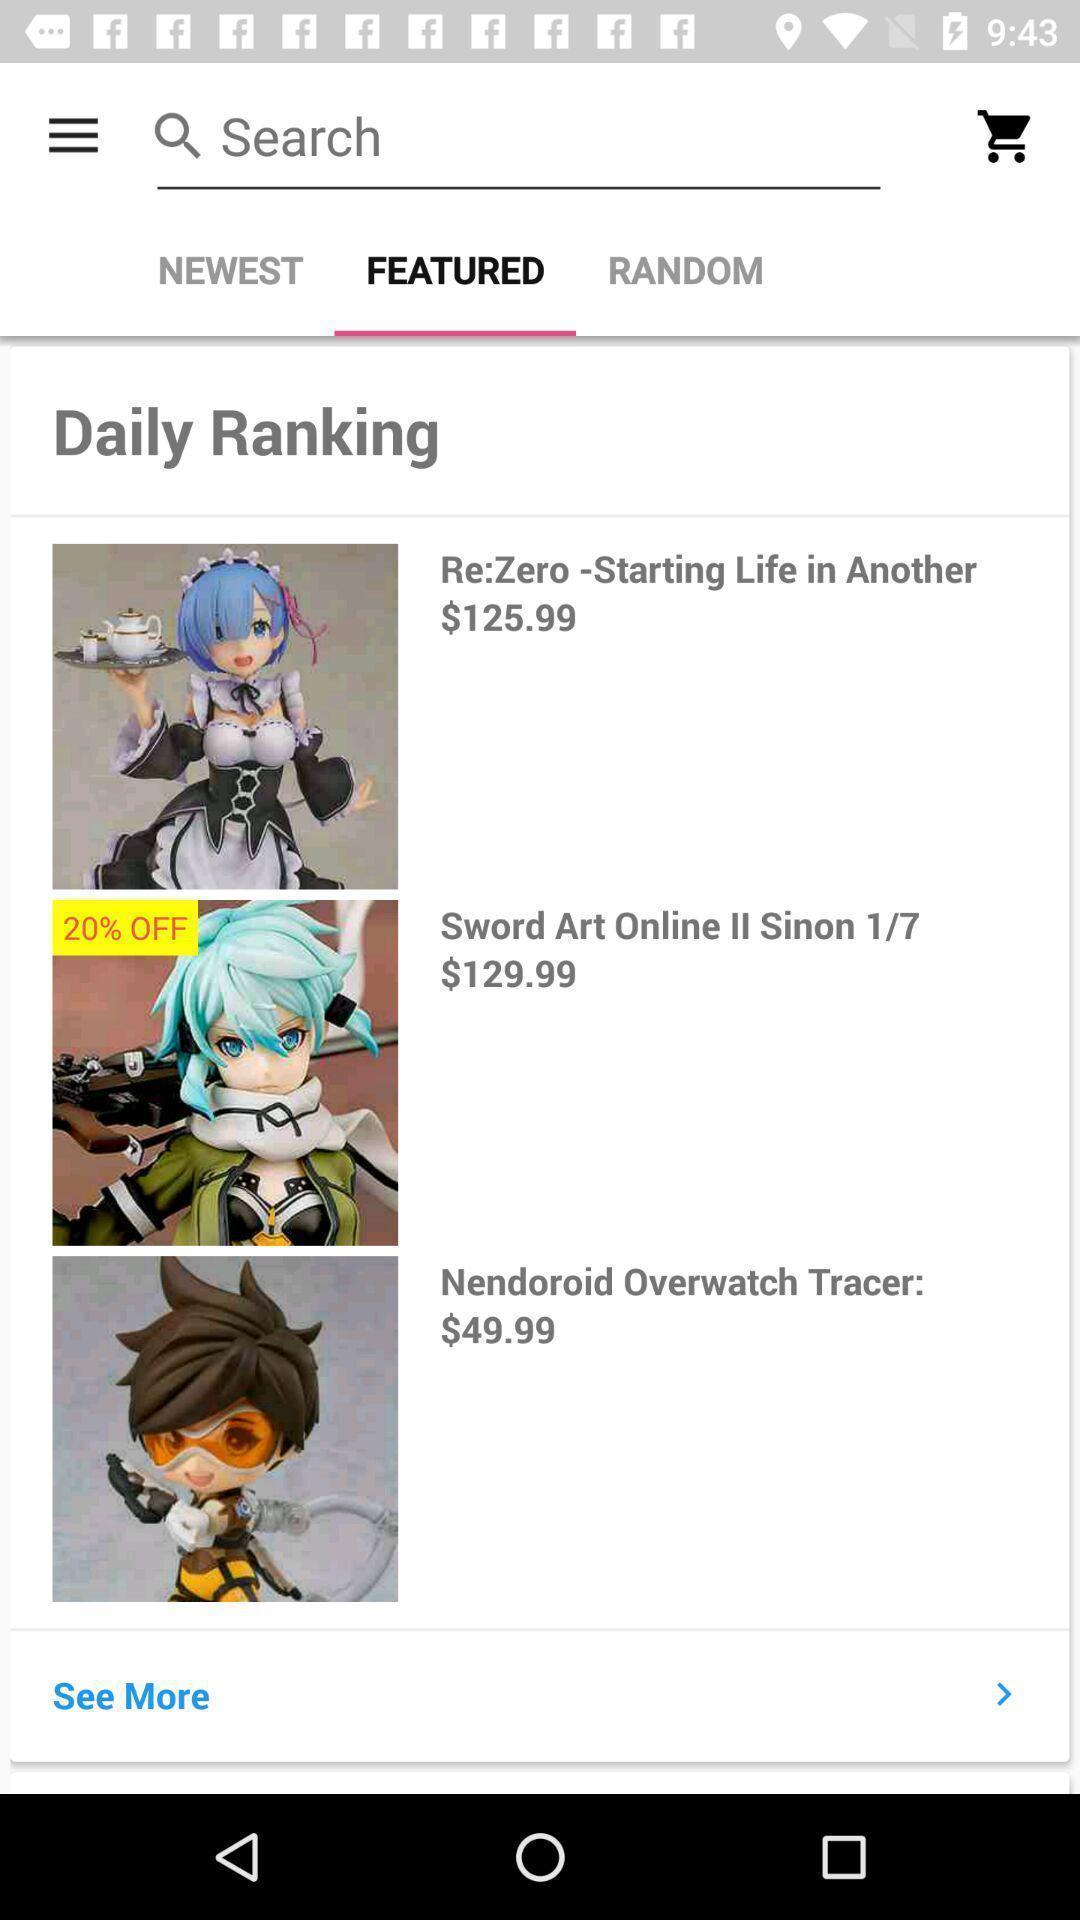Please provide a description for this image. Ranking of featured novels of online shopping app. 